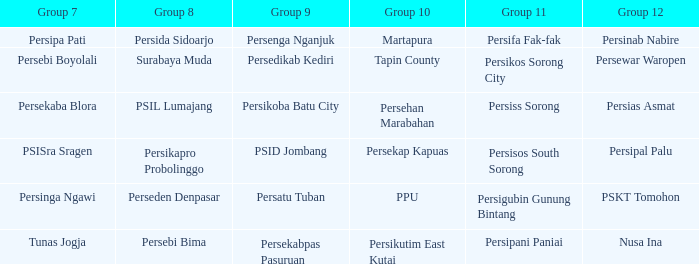When  persikos sorong city played in group 11, who played in group 7? Persebi Boyolali. 